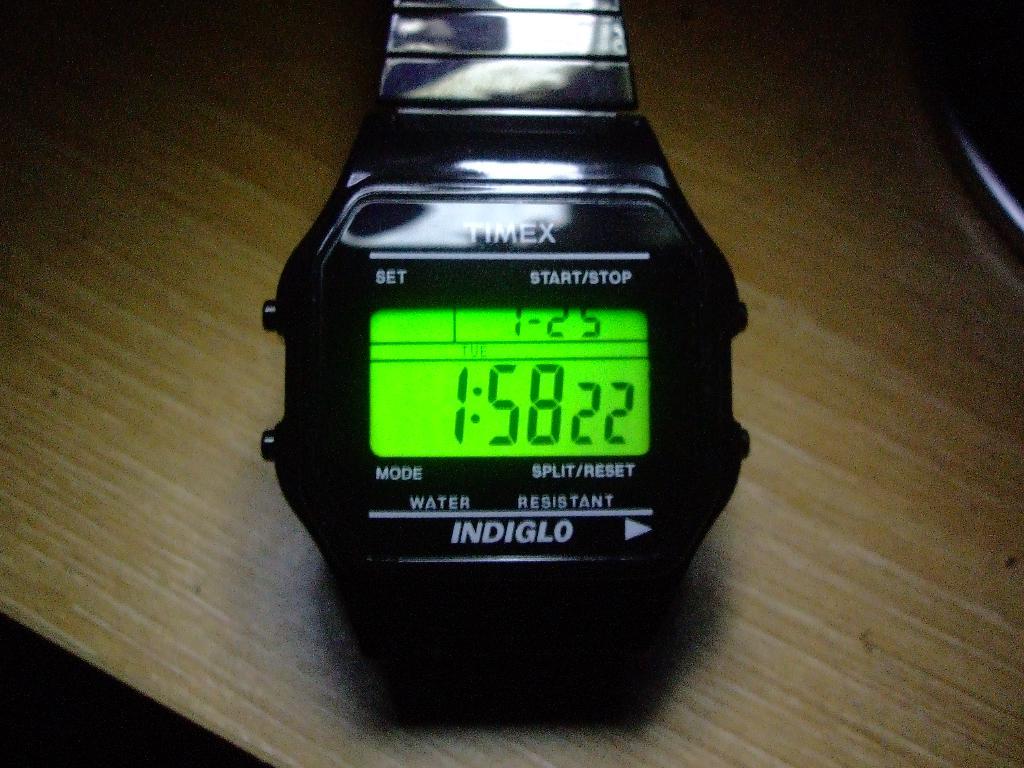What is the brand name on the watch?
Provide a short and direct response. Timex. 